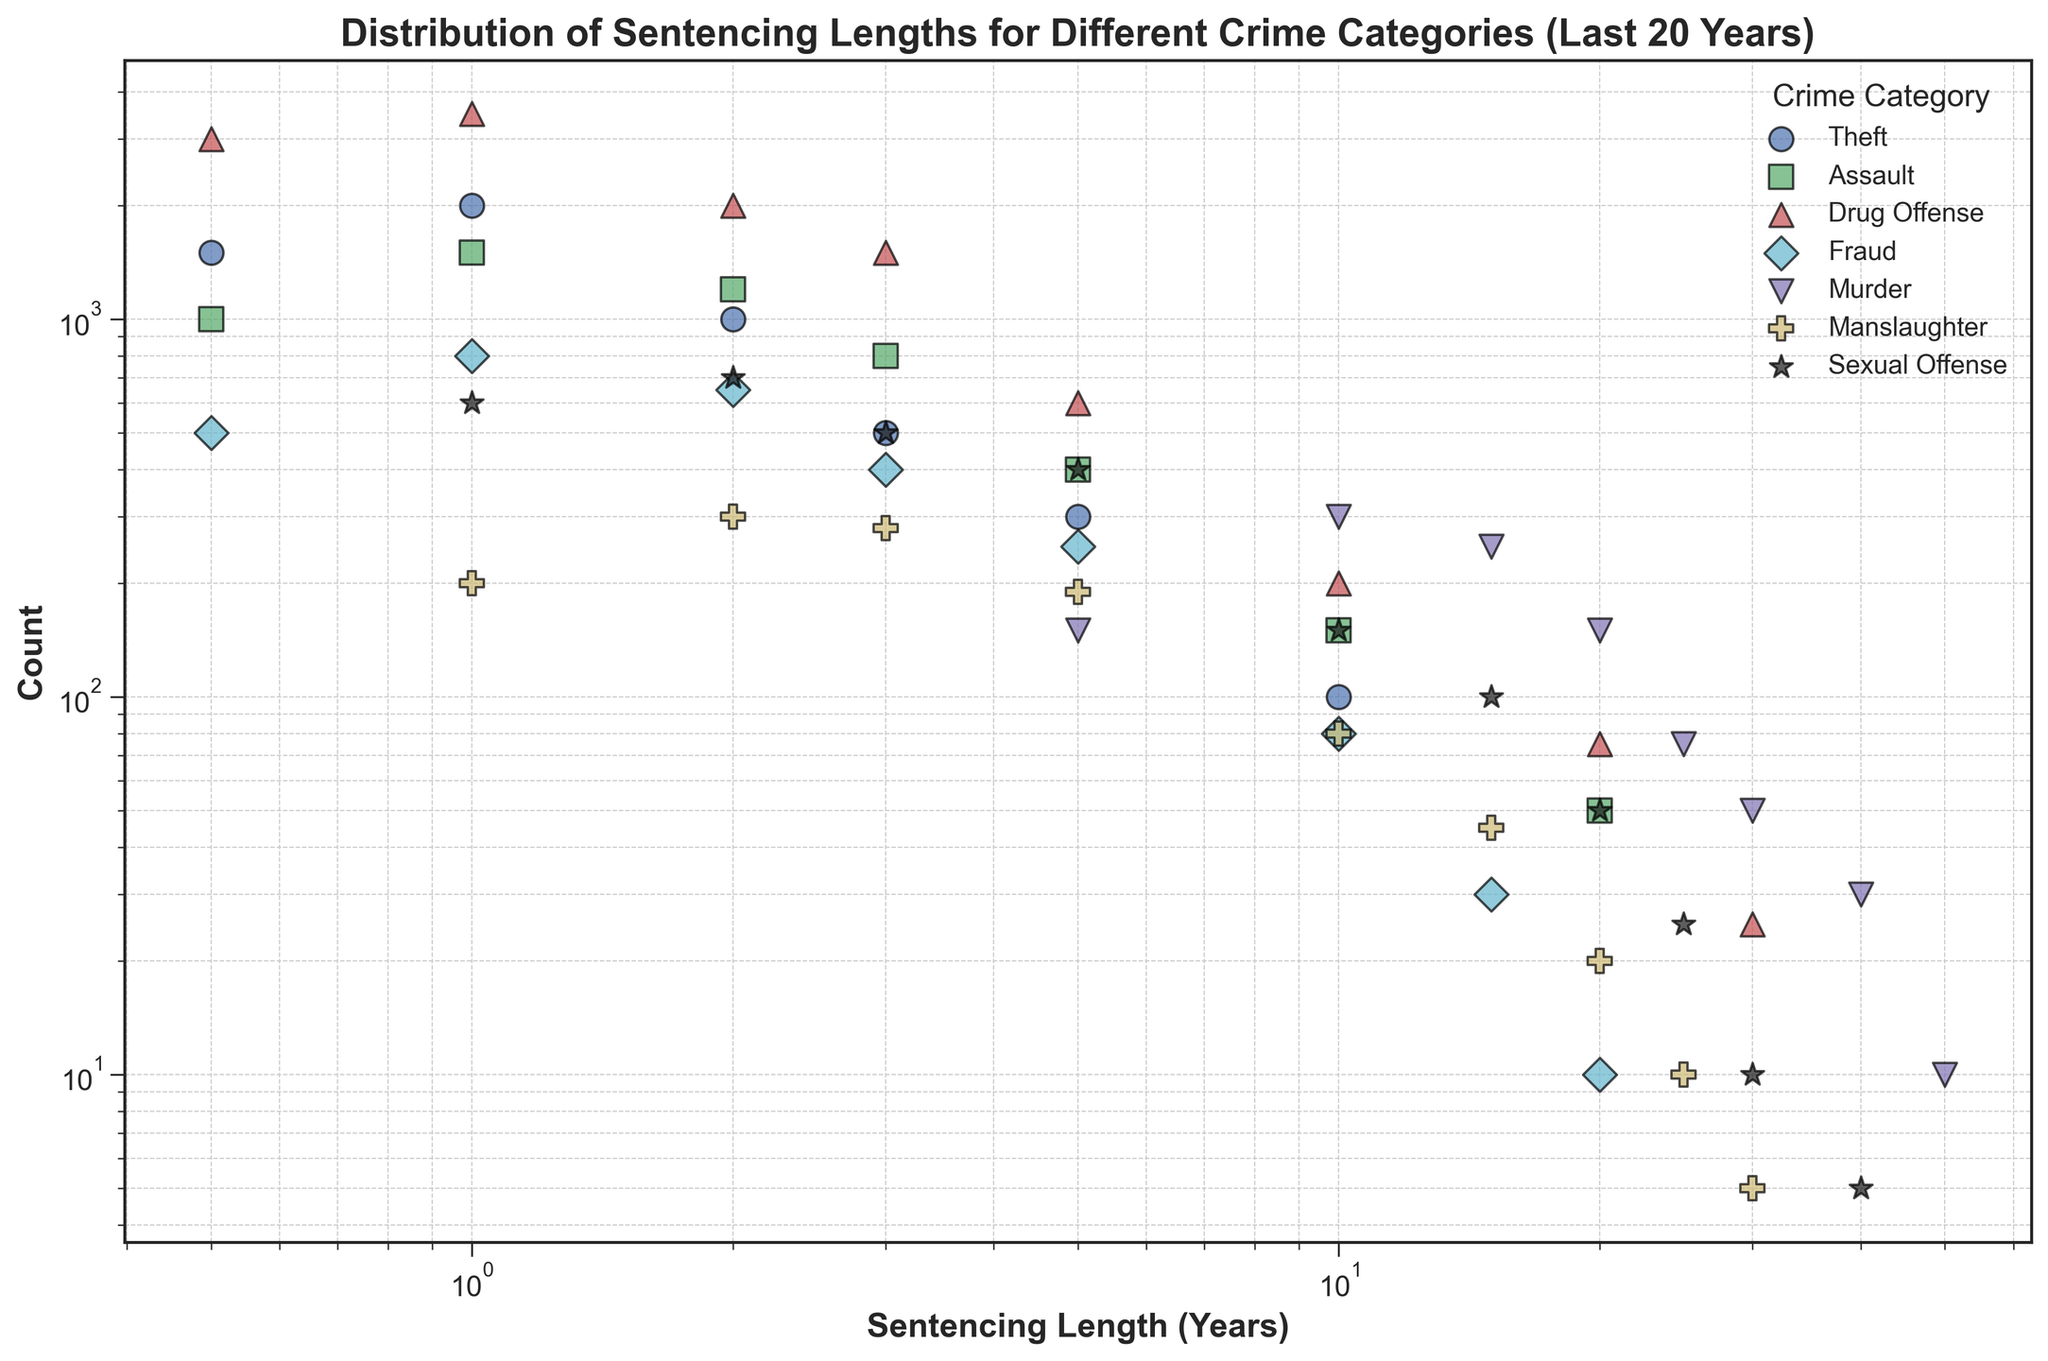What's the crime category with the highest count for a 0.5-year sentencing length? To find the crime category with the highest count for a 0.5-year sentencing length, look at the y-axis value corresponding to the x-axis value of 0.5 years. The crime category "Drug Offense" has the highest count at this sentencing length as it is visibly the highest point on the y-axis.
Answer: Drug Offense Which crime category has the longest sentencing length observed in the data? To determine the crime category with the longest sentencing length, check the maximum value on the x-axis. The largest value, 50 years, is associated with the "Murder" category.
Answer: Murder What is the predominant sentencing length range for "Fraud"? To identify the predominant sentencing length range for "Fraud," observe the data points for "Fraud" on the x-axis. Most counts are concentrated around the lower end from 0.5 to 5 years, with fewer cases extending up to 20 years.
Answer: 0.5 to 5 years Compare the count of sentencing lengths for "Murder" at 10 years and "Manslaughter" at 10 years. Which is higher, and by how much? Look at the counts on the y-axis corresponding to 10 years on the x-axis for both "Murder" and "Manslaughter." "Murder" has 300 counts and "Manslaughter" has 80 counts. The count for "Murder" is higher by 300 - 80 = 220.
Answer: Murder by 220 Which category has a visible count for the 40-year sentencing length? Find the 40-year mark on the x-axis and examine the data point associated with it. The "Murder" and "Sexual Offense" categories both have counts at this sentencing length. "Murder" has a higher count compared to "Sexual Offense."
Answer: Murder and Sexual Offense What fraction of the total counts for "Assault" are for sentences of 2 years or less? To find this fraction, sum the counts for sentencing lengths of 2 years or less for "Assault" (1000 + 1500 + 1200 = 3700) and divide it by the total counts for "Assault" (1000 + 1500 + 1200 + 800 + 400 + 150 + 50 = 5150). The fraction is 3700 / 5150 = 0.718.
Answer: 0.718 Which crime category shows a clear trend of significantly decreasing counts with increasing sentence lengths? Observe data points across several categories and look for a clear decreasing trend. "Murder" category shows a significant decrease in counts as sentencing length increases, peaking at 10 years and dropping noticeably towards higher sentencing lengths.
Answer: Murder Are there more "Theft" sentences at 5 years or "Assault" sentences at 5 years, and by what margin? Identify the counts for "Theft" and "Assault" at the 5-year sentencing mark on the x-axis. "Theft" has 300 counts while "Assault" has 400 counts. The margin is 400 - 300 = 100.
Answer: Assault by 100 What is the average sentencing length for categories where sentencing length hits up to 30 years? Identify the categories with data points reaching up to 30 years: "Drug Offense," "Murder," "Manslaughter," "Sexual Offense." The sentencing lengths for these categories are respectively 30, 50, 30, and 30 years. The average is calculated as (30 + 50 + 30 + 30) / 4 = 35.
Answer: 35 